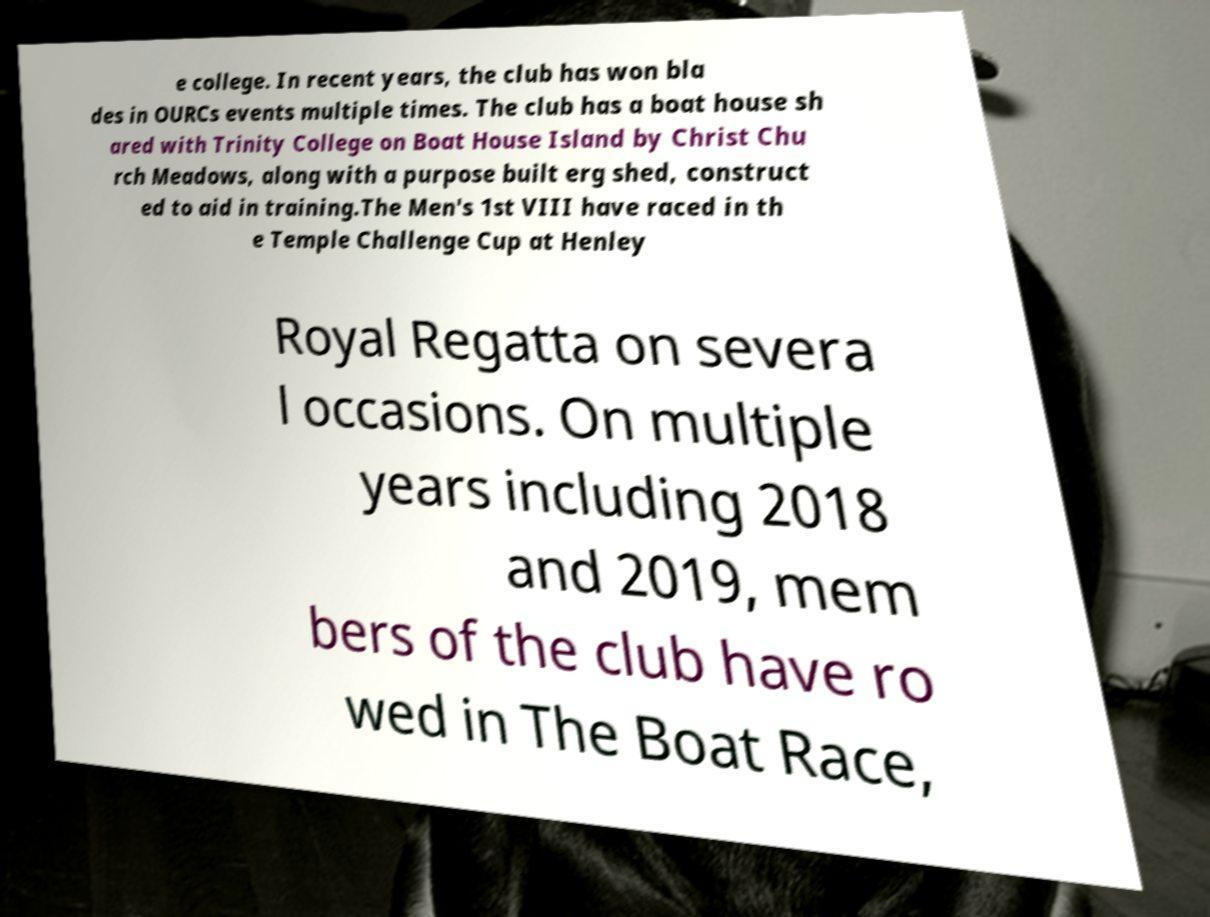Can you read and provide the text displayed in the image?This photo seems to have some interesting text. Can you extract and type it out for me? e college. In recent years, the club has won bla des in OURCs events multiple times. The club has a boat house sh ared with Trinity College on Boat House Island by Christ Chu rch Meadows, along with a purpose built erg shed, construct ed to aid in training.The Men's 1st VIII have raced in th e Temple Challenge Cup at Henley Royal Regatta on severa l occasions. On multiple years including 2018 and 2019, mem bers of the club have ro wed in The Boat Race, 